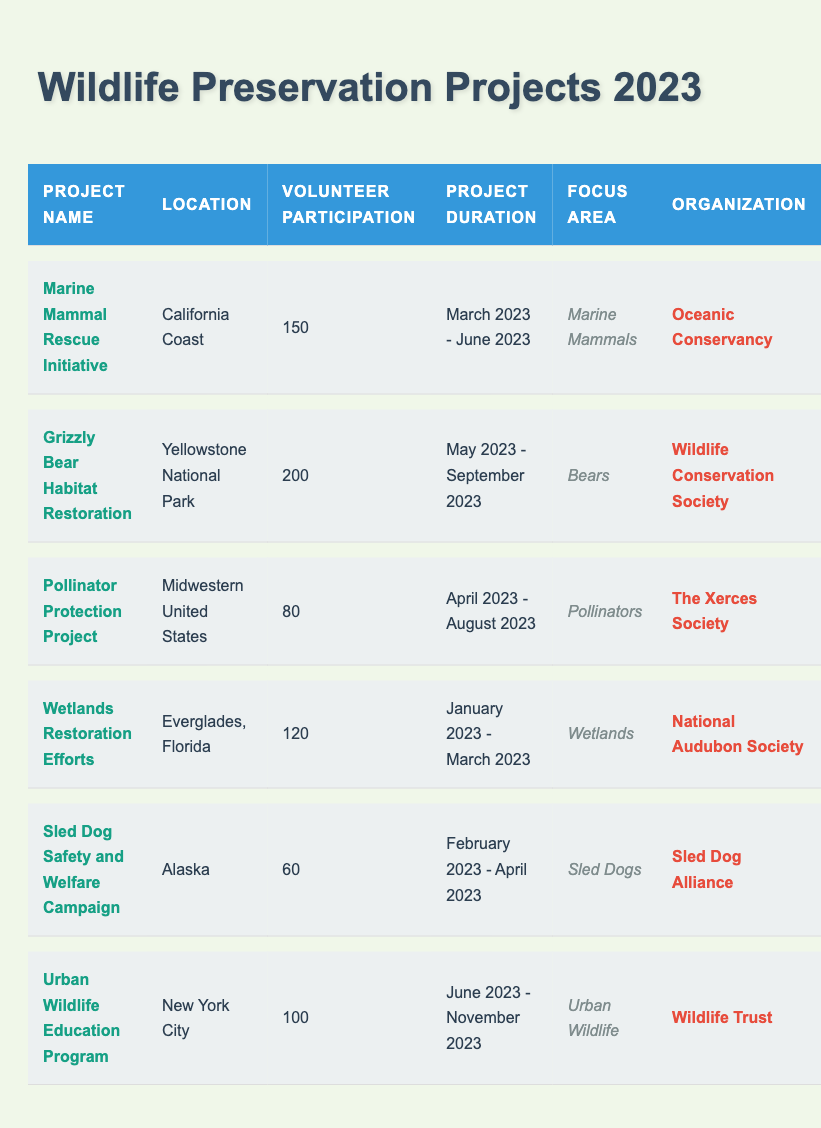What is the project with the highest volunteer participation? The table shows that "Grizzly Bear Habitat Restoration" has the highest volunteer participation, with 200 volunteers.
Answer: Grizzly Bear Habitat Restoration How many volunteers participated in the Sled Dog Safety and Welfare Campaign? The table indicates that there were 60 volunteers for the Sled Dog Safety and Welfare Campaign.
Answer: 60 What is the location of the Urban Wildlife Education Program? According to the table, the Urban Wildlife Education Program is located in New York City.
Answer: New York City What is the total volunteer participation across all projects listed? To find the total, sum the volunteer participation: 150 + 200 + 80 + 120 + 60 + 100 = 710.
Answer: 710 In which month did the Marine Mammal Rescue Initiative start? The project duration for the Marine Mammal Rescue Initiative starts in March 2023, as shown in the table.
Answer: March 2023 What is the average volunteer participation for all projects? First, sum the total volunteers (710), then divide by the number of projects (6): 710 / 6 = 118.33.
Answer: 118.33 Was the Wetlands Restoration Efforts project focused on pollinators? The focus area for Wetlands Restoration Efforts is listed as Wetlands, so the answer is no.
Answer: No Which project has the shortest duration? By analyzing the project durations, the Wetlands Restoration Efforts is the shortest, lasting from January to March 2023.
Answer: Wetlands Restoration Efforts How many projects were focused on marine mammals? Referring to the table, there is one project specifically focused on marine mammals, which is the Marine Mammal Rescue Initiative.
Answer: 1 Which organization is associated with the Pollinator Protection Project? The table shows that the Pollinator Protection Project is associated with The Xerces Society.
Answer: The Xerces Society 